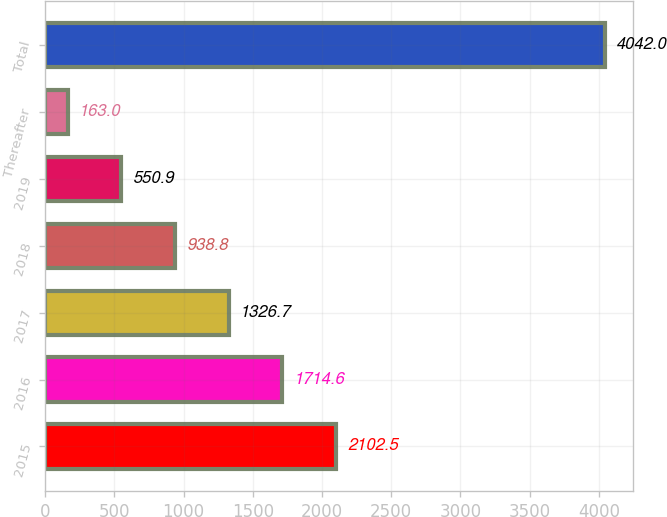Convert chart to OTSL. <chart><loc_0><loc_0><loc_500><loc_500><bar_chart><fcel>2015<fcel>2016<fcel>2017<fcel>2018<fcel>2019<fcel>Thereafter<fcel>Total<nl><fcel>2102.5<fcel>1714.6<fcel>1326.7<fcel>938.8<fcel>550.9<fcel>163<fcel>4042<nl></chart> 